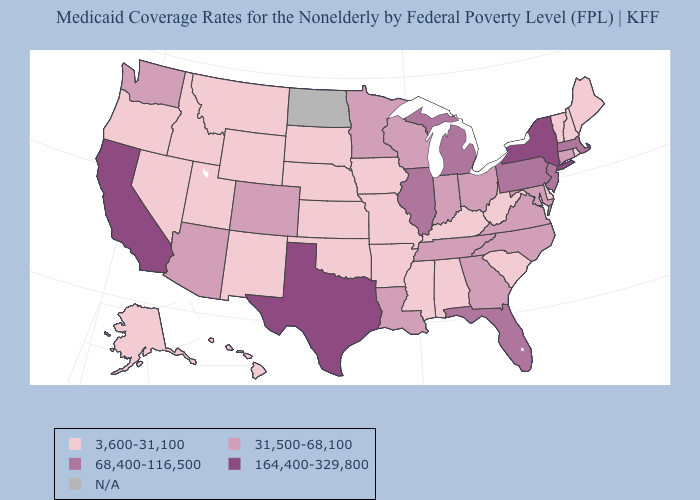What is the value of Pennsylvania?
Concise answer only. 68,400-116,500. What is the value of Florida?
Keep it brief. 68,400-116,500. Name the states that have a value in the range N/A?
Write a very short answer. North Dakota. Name the states that have a value in the range 3,600-31,100?
Write a very short answer. Alabama, Alaska, Arkansas, Delaware, Hawaii, Idaho, Iowa, Kansas, Kentucky, Maine, Mississippi, Missouri, Montana, Nebraska, Nevada, New Hampshire, New Mexico, Oklahoma, Oregon, Rhode Island, South Carolina, South Dakota, Utah, Vermont, West Virginia, Wyoming. Name the states that have a value in the range 164,400-329,800?
Short answer required. California, New York, Texas. Does New Jersey have the lowest value in the USA?
Short answer required. No. Does the map have missing data?
Write a very short answer. Yes. What is the value of Iowa?
Answer briefly. 3,600-31,100. What is the value of South Carolina?
Concise answer only. 3,600-31,100. Which states hav the highest value in the West?
Give a very brief answer. California. Name the states that have a value in the range 68,400-116,500?
Give a very brief answer. Florida, Illinois, Massachusetts, Michigan, New Jersey, Pennsylvania. What is the value of Connecticut?
Short answer required. 31,500-68,100. Name the states that have a value in the range 164,400-329,800?
Keep it brief. California, New York, Texas. Which states hav the highest value in the West?
Short answer required. California. 